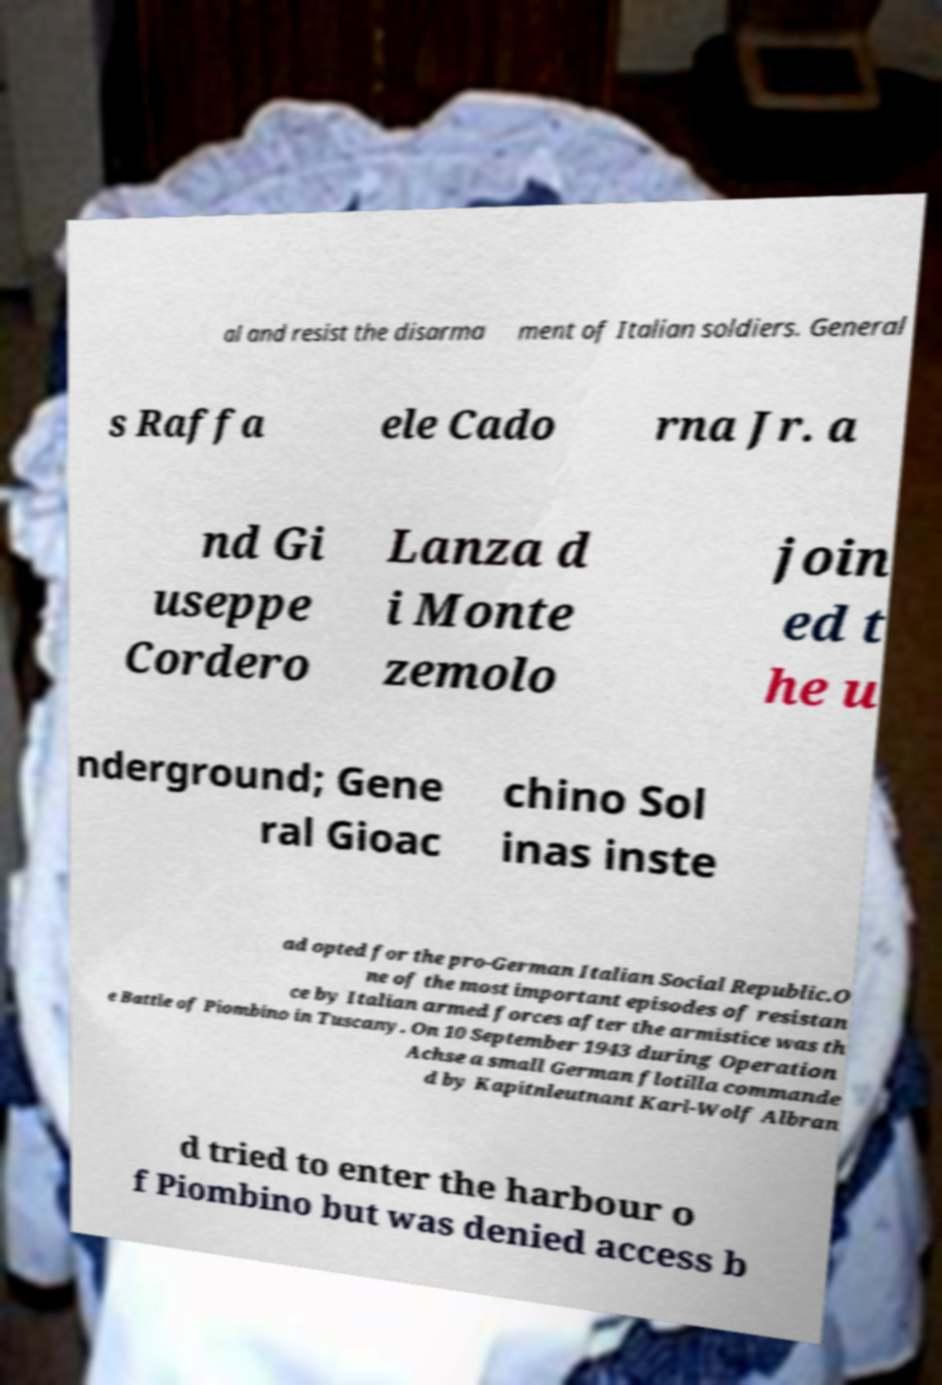I need the written content from this picture converted into text. Can you do that? al and resist the disarma ment of Italian soldiers. General s Raffa ele Cado rna Jr. a nd Gi useppe Cordero Lanza d i Monte zemolo join ed t he u nderground; Gene ral Gioac chino Sol inas inste ad opted for the pro-German Italian Social Republic.O ne of the most important episodes of resistan ce by Italian armed forces after the armistice was th e Battle of Piombino in Tuscany. On 10 September 1943 during Operation Achse a small German flotilla commande d by Kapitnleutnant Karl-Wolf Albran d tried to enter the harbour o f Piombino but was denied access b 